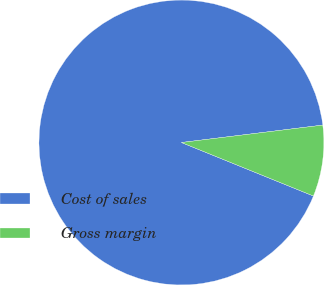Convert chart to OTSL. <chart><loc_0><loc_0><loc_500><loc_500><pie_chart><fcel>Cost of sales<fcel>Gross margin<nl><fcel>91.92%<fcel>8.08%<nl></chart> 